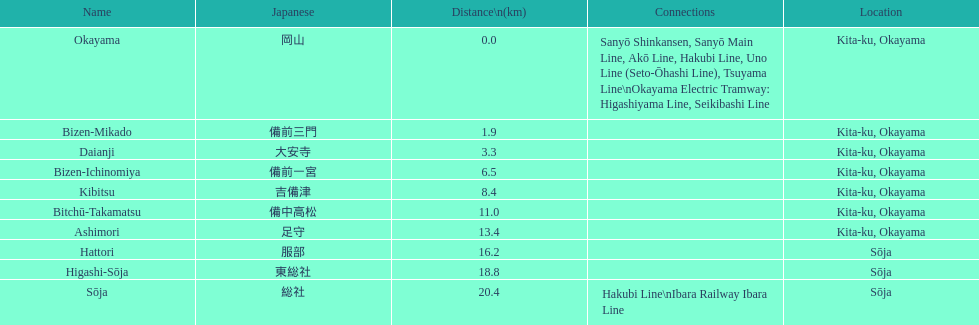Would you be able to parse every entry in this table? {'header': ['Name', 'Japanese', 'Distance\\n(km)', 'Connections', 'Location'], 'rows': [['Okayama', '岡山', '0.0', 'Sanyō Shinkansen, Sanyō Main Line, Akō Line, Hakubi Line, Uno Line (Seto-Ōhashi Line), Tsuyama Line\\nOkayama Electric Tramway: Higashiyama Line, Seikibashi Line', 'Kita-ku, Okayama'], ['Bizen-Mikado', '備前三門', '1.9', '', 'Kita-ku, Okayama'], ['Daianji', '大安寺', '3.3', '', 'Kita-ku, Okayama'], ['Bizen-Ichinomiya', '備前一宮', '6.5', '', 'Kita-ku, Okayama'], ['Kibitsu', '吉備津', '8.4', '', 'Kita-ku, Okayama'], ['Bitchū-Takamatsu', '備中高松', '11.0', '', 'Kita-ku, Okayama'], ['Ashimori', '足守', '13.4', '', 'Kita-ku, Okayama'], ['Hattori', '服部', '16.2', '', 'Sōja'], ['Higashi-Sōja', '東総社', '18.8', '', 'Sōja'], ['Sōja', '総社', '20.4', 'Hakubi Line\\nIbara Railway Ibara Line', 'Sōja']]} How many stations have a distance below 15km? 7. 